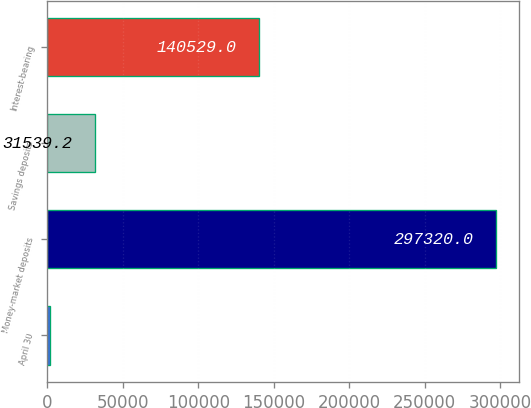<chart> <loc_0><loc_0><loc_500><loc_500><bar_chart><fcel>April 30<fcel>Money-market deposits<fcel>Savings deposits<fcel>Interest-bearing<nl><fcel>2008<fcel>297320<fcel>31539.2<fcel>140529<nl></chart> 